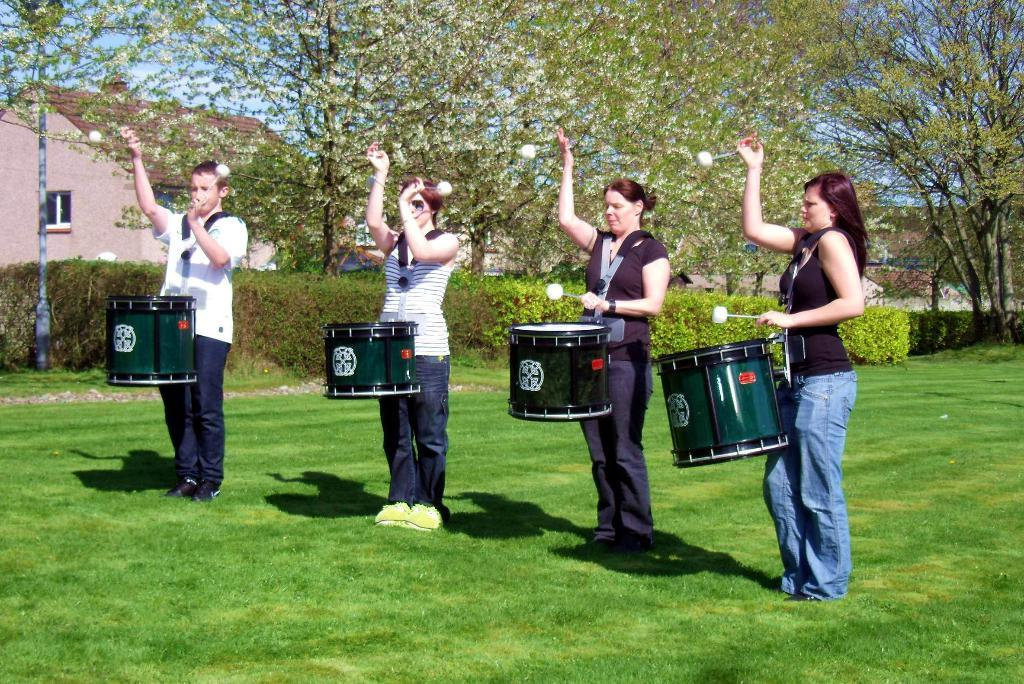How many people are in the image? There are four persons in the image. What are the persons carrying? Each person is carrying a drum. What are the persons holding in their hands? The persons are holding drum sticks in their hands. What can be seen on the ground in the image? There is greenery on the ground. What is visible in the background of the image? There are trees and buildings visible in the background. What type of yam is being used as a prop in the image? There is no yam present in the image; the persons are carrying drums and holding drum sticks. 